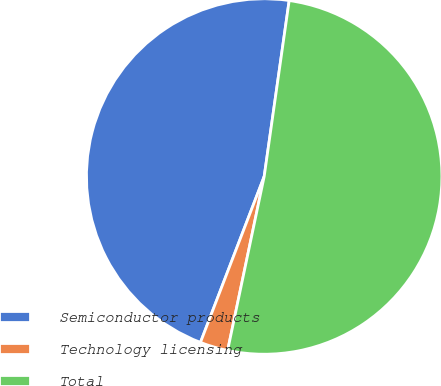Convert chart to OTSL. <chart><loc_0><loc_0><loc_500><loc_500><pie_chart><fcel>Semiconductor products<fcel>Technology licensing<fcel>Total<nl><fcel>46.41%<fcel>2.54%<fcel>51.05%<nl></chart> 